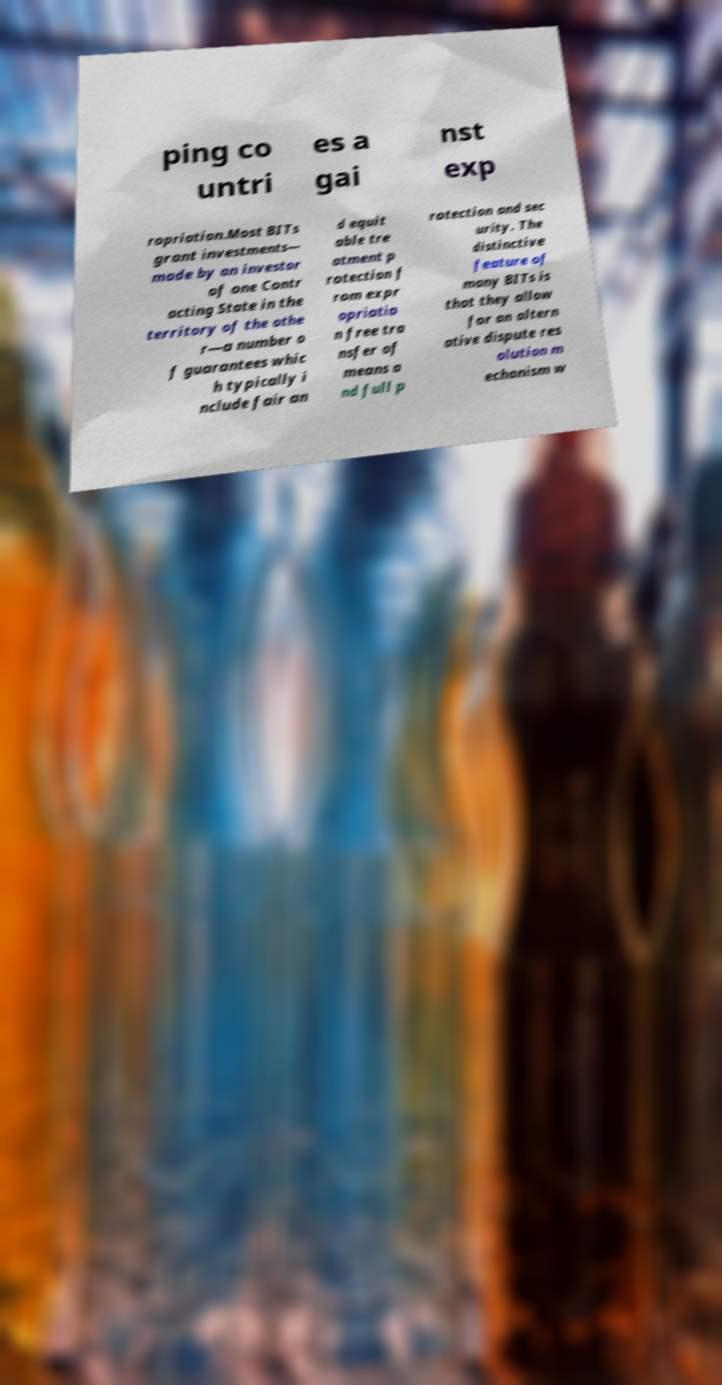I need the written content from this picture converted into text. Can you do that? ping co untri es a gai nst exp ropriation.Most BITs grant investments— made by an investor of one Contr acting State in the territory of the othe r—a number o f guarantees whic h typically i nclude fair an d equit able tre atment p rotection f rom expr opriatio n free tra nsfer of means a nd full p rotection and sec urity. The distinctive feature of many BITs is that they allow for an altern ative dispute res olution m echanism w 